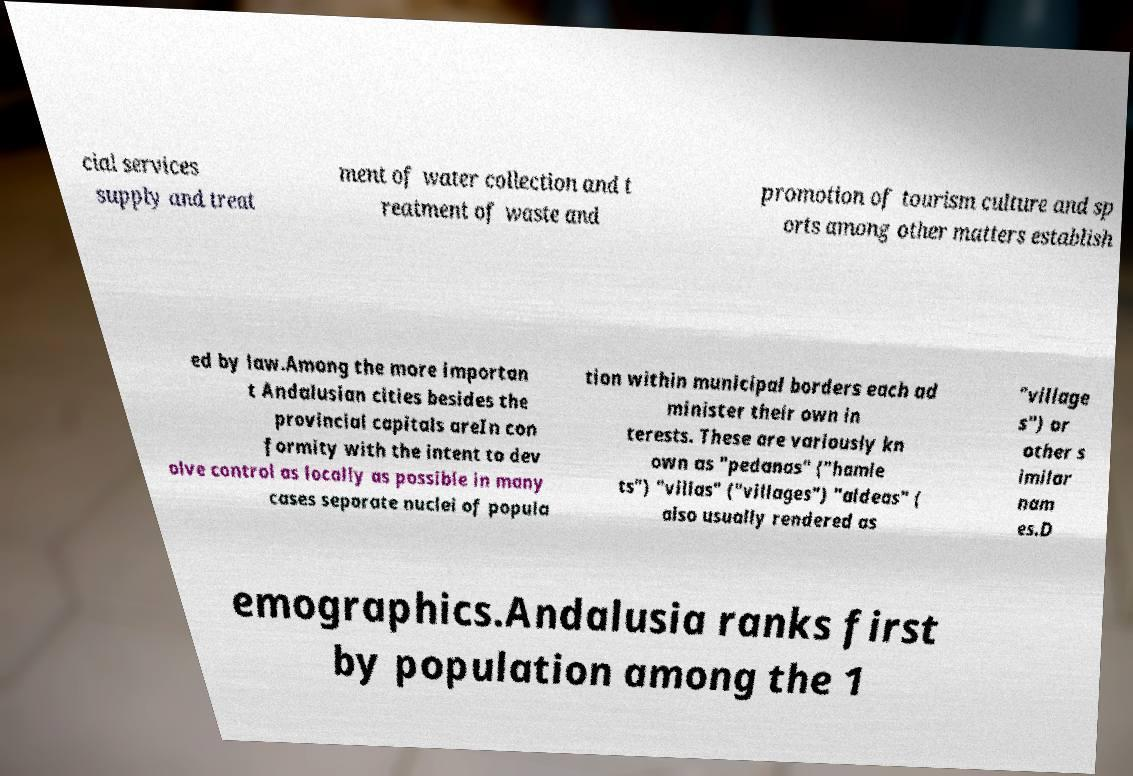Could you extract and type out the text from this image? cial services supply and treat ment of water collection and t reatment of waste and promotion of tourism culture and sp orts among other matters establish ed by law.Among the more importan t Andalusian cities besides the provincial capitals areIn con formity with the intent to dev olve control as locally as possible in many cases separate nuclei of popula tion within municipal borders each ad minister their own in terests. These are variously kn own as "pedanas" ("hamle ts") "villas" ("villages") "aldeas" ( also usually rendered as "village s") or other s imilar nam es.D emographics.Andalusia ranks first by population among the 1 